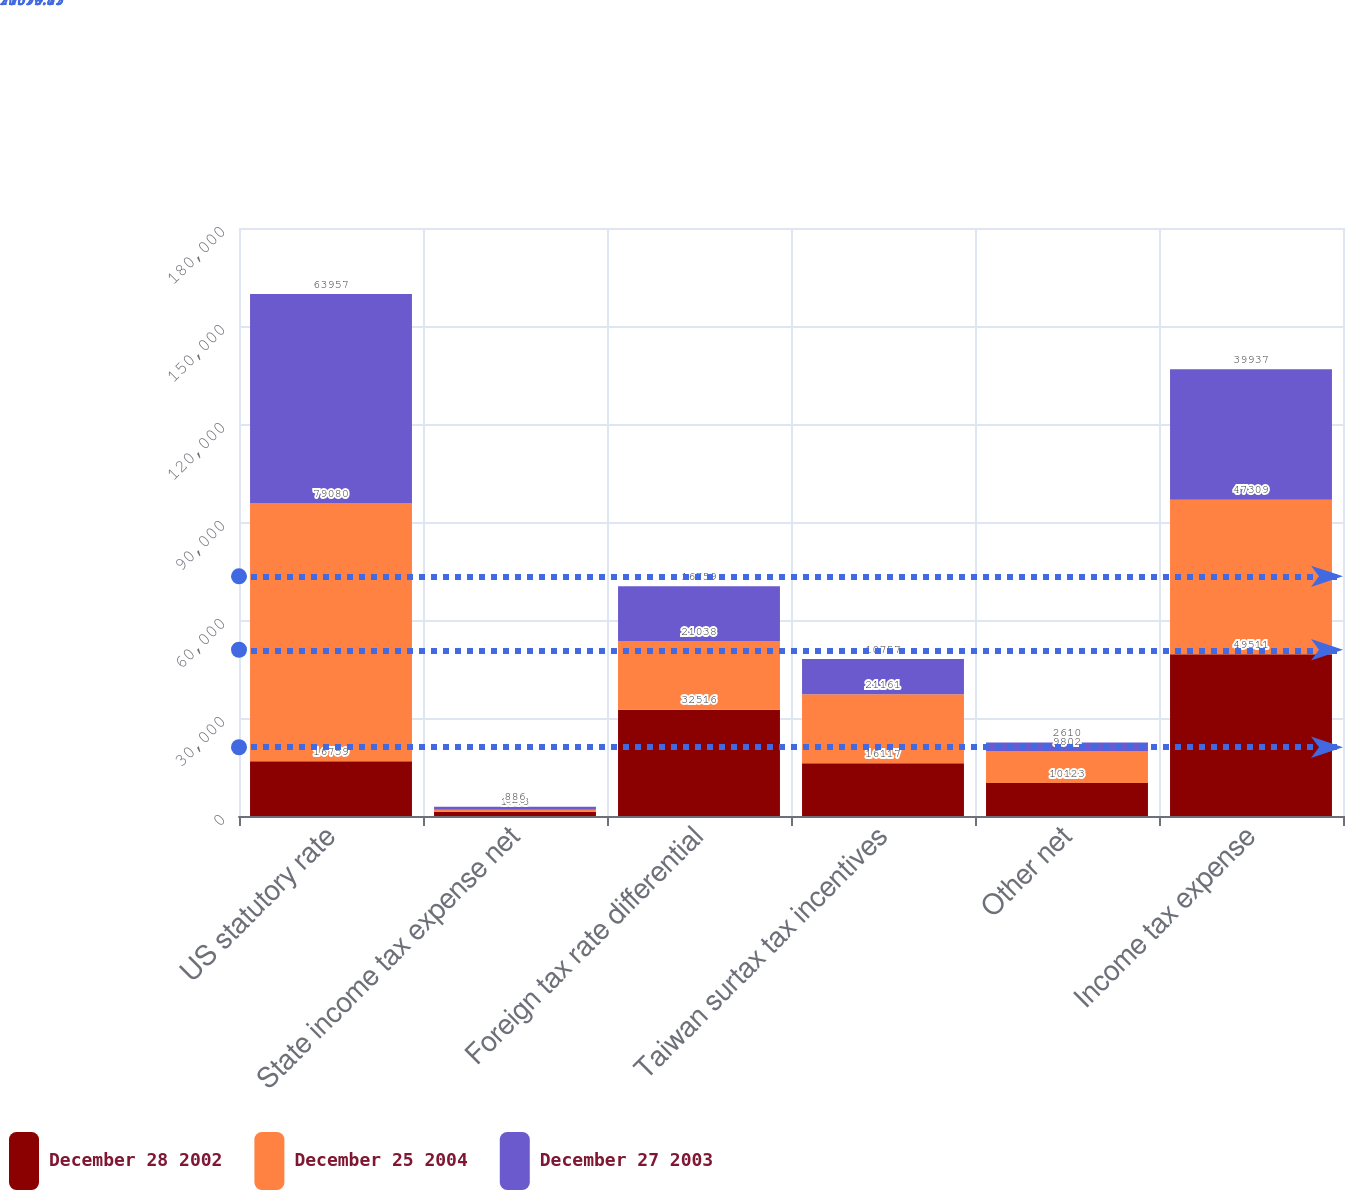<chart> <loc_0><loc_0><loc_500><loc_500><stacked_bar_chart><ecel><fcel>US statutory rate<fcel>State income tax expense net<fcel>Foreign tax rate differential<fcel>Taiwan surtax tax incentives<fcel>Other net<fcel>Income tax expense<nl><fcel>December 28 2002<fcel>16759<fcel>1303<fcel>32516<fcel>16117<fcel>10123<fcel>49511<nl><fcel>December 25 2004<fcel>79080<fcel>626<fcel>21038<fcel>21161<fcel>9802<fcel>47309<nl><fcel>December 27 2003<fcel>63957<fcel>886<fcel>16759<fcel>10757<fcel>2610<fcel>39937<nl></chart> 